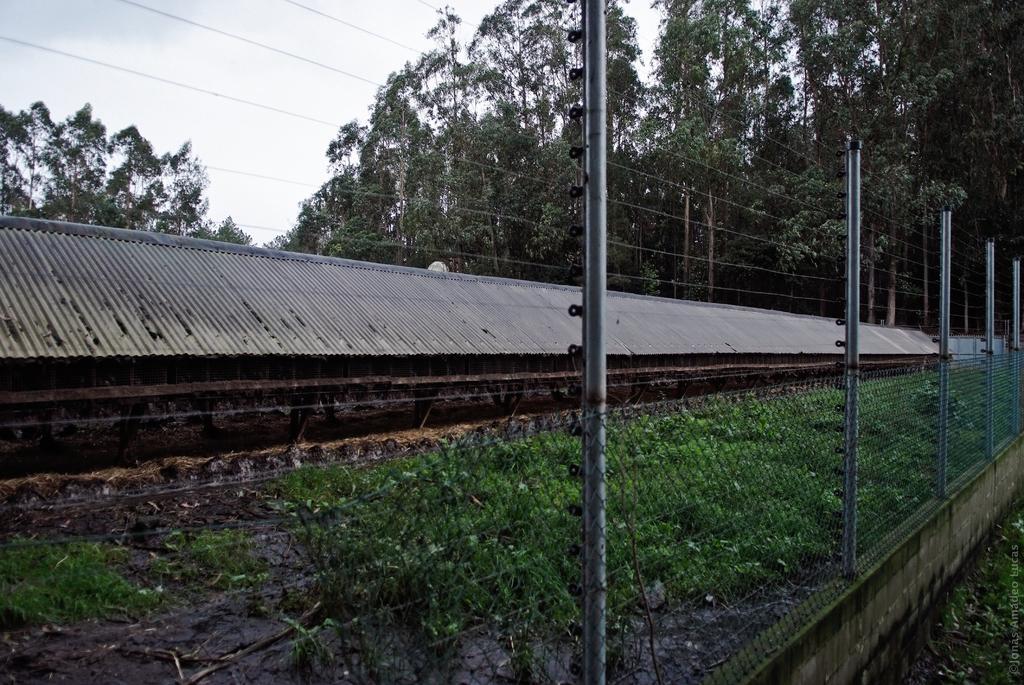Please provide a concise description of this image. In this picture we can observe a long shed. We can observe some plants on the ground. There is a fence. In the background there are trees and a sky. 